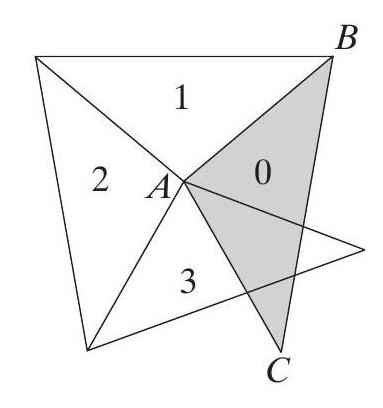Can you explain how the angles of each triangle change as we progress in the spiral? In the spiral, each triangle maintains an internal angle of 100° at the vertex connecting two equal sides. As we move from one triangle to another in a counterclockwise direction, this stay-fixed angle ensures that each triangle is an isosceles triangle mirroring the others but rotating slightly around a central point. 